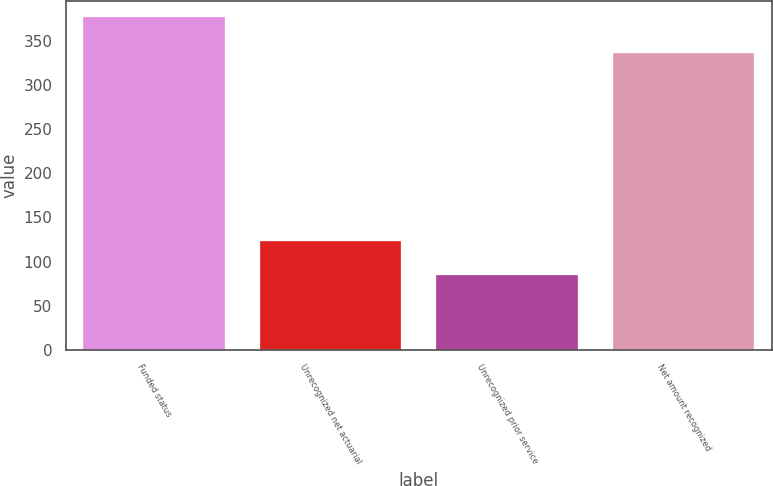Convert chart to OTSL. <chart><loc_0><loc_0><loc_500><loc_500><bar_chart><fcel>Funded status<fcel>Unrecognized net actuarial<fcel>Unrecognized prior service<fcel>Net amount recognized<nl><fcel>377<fcel>123<fcel>85<fcel>337<nl></chart> 